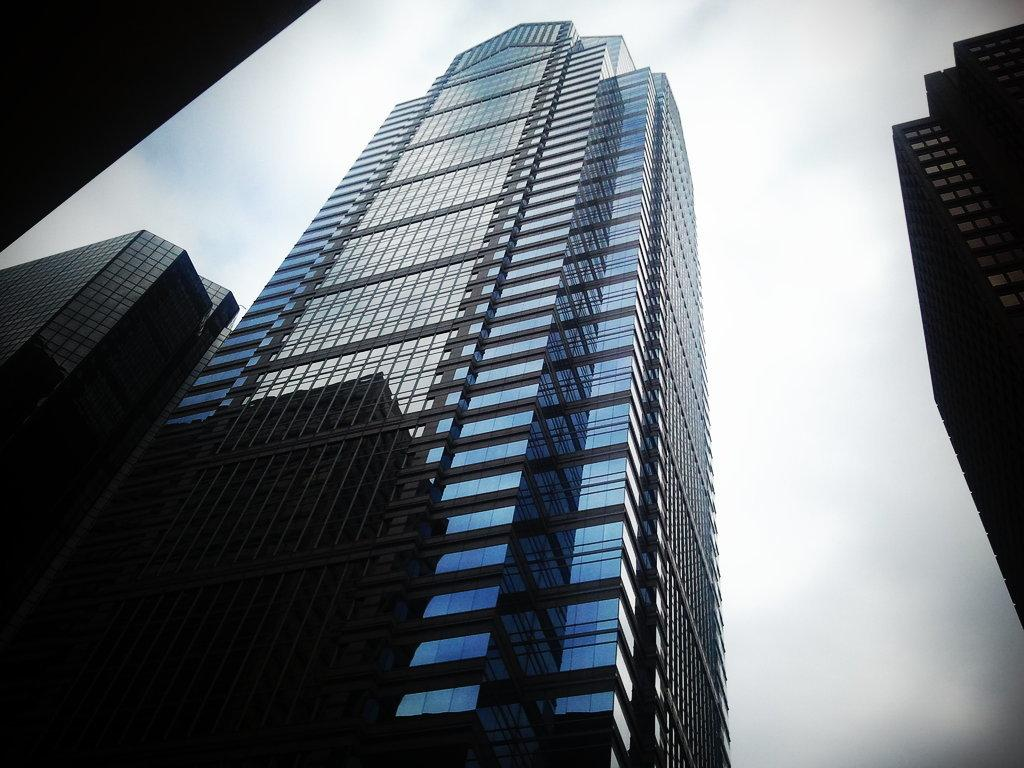What type of structures are present in the image? There are buildings in the picture. What feature can be observed on the buildings? The buildings have glass windows. What is the condition of the sky in the image? The sky is clear in the picture. Can you tell me how many people are participating in the discussion about the earthquake in the image? There is no discussion about an earthquake or any people present in the image; it only features buildings with glass windows and a clear sky. 